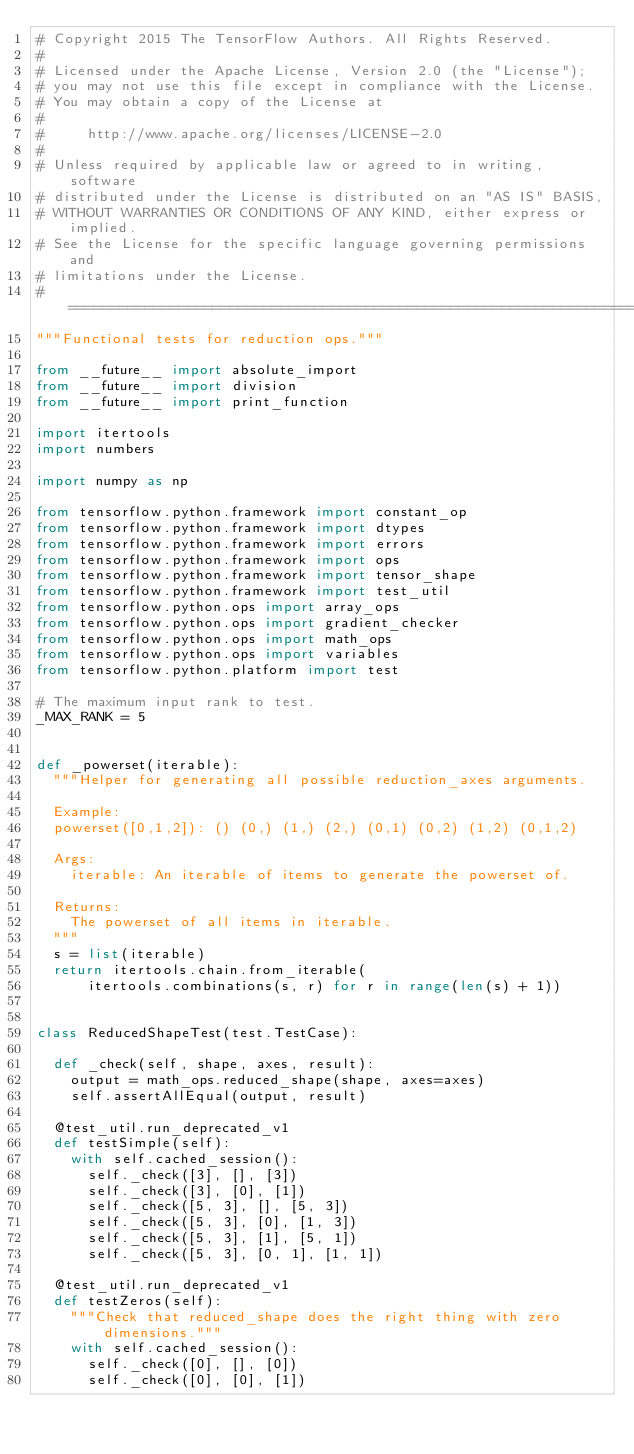<code> <loc_0><loc_0><loc_500><loc_500><_Python_># Copyright 2015 The TensorFlow Authors. All Rights Reserved.
#
# Licensed under the Apache License, Version 2.0 (the "License");
# you may not use this file except in compliance with the License.
# You may obtain a copy of the License at
#
#     http://www.apache.org/licenses/LICENSE-2.0
#
# Unless required by applicable law or agreed to in writing, software
# distributed under the License is distributed on an "AS IS" BASIS,
# WITHOUT WARRANTIES OR CONDITIONS OF ANY KIND, either express or implied.
# See the License for the specific language governing permissions and
# limitations under the License.
# ==============================================================================
"""Functional tests for reduction ops."""

from __future__ import absolute_import
from __future__ import division
from __future__ import print_function

import itertools
import numbers

import numpy as np

from tensorflow.python.framework import constant_op
from tensorflow.python.framework import dtypes
from tensorflow.python.framework import errors
from tensorflow.python.framework import ops
from tensorflow.python.framework import tensor_shape
from tensorflow.python.framework import test_util
from tensorflow.python.ops import array_ops
from tensorflow.python.ops import gradient_checker
from tensorflow.python.ops import math_ops
from tensorflow.python.ops import variables
from tensorflow.python.platform import test

# The maximum input rank to test.
_MAX_RANK = 5


def _powerset(iterable):
  """Helper for generating all possible reduction_axes arguments.

  Example:
  powerset([0,1,2]): () (0,) (1,) (2,) (0,1) (0,2) (1,2) (0,1,2)

  Args:
    iterable: An iterable of items to generate the powerset of.

  Returns:
    The powerset of all items in iterable.
  """
  s = list(iterable)
  return itertools.chain.from_iterable(
      itertools.combinations(s, r) for r in range(len(s) + 1))


class ReducedShapeTest(test.TestCase):

  def _check(self, shape, axes, result):
    output = math_ops.reduced_shape(shape, axes=axes)
    self.assertAllEqual(output, result)

  @test_util.run_deprecated_v1
  def testSimple(self):
    with self.cached_session():
      self._check([3], [], [3])
      self._check([3], [0], [1])
      self._check([5, 3], [], [5, 3])
      self._check([5, 3], [0], [1, 3])
      self._check([5, 3], [1], [5, 1])
      self._check([5, 3], [0, 1], [1, 1])

  @test_util.run_deprecated_v1
  def testZeros(self):
    """Check that reduced_shape does the right thing with zero dimensions."""
    with self.cached_session():
      self._check([0], [], [0])
      self._check([0], [0], [1])</code> 